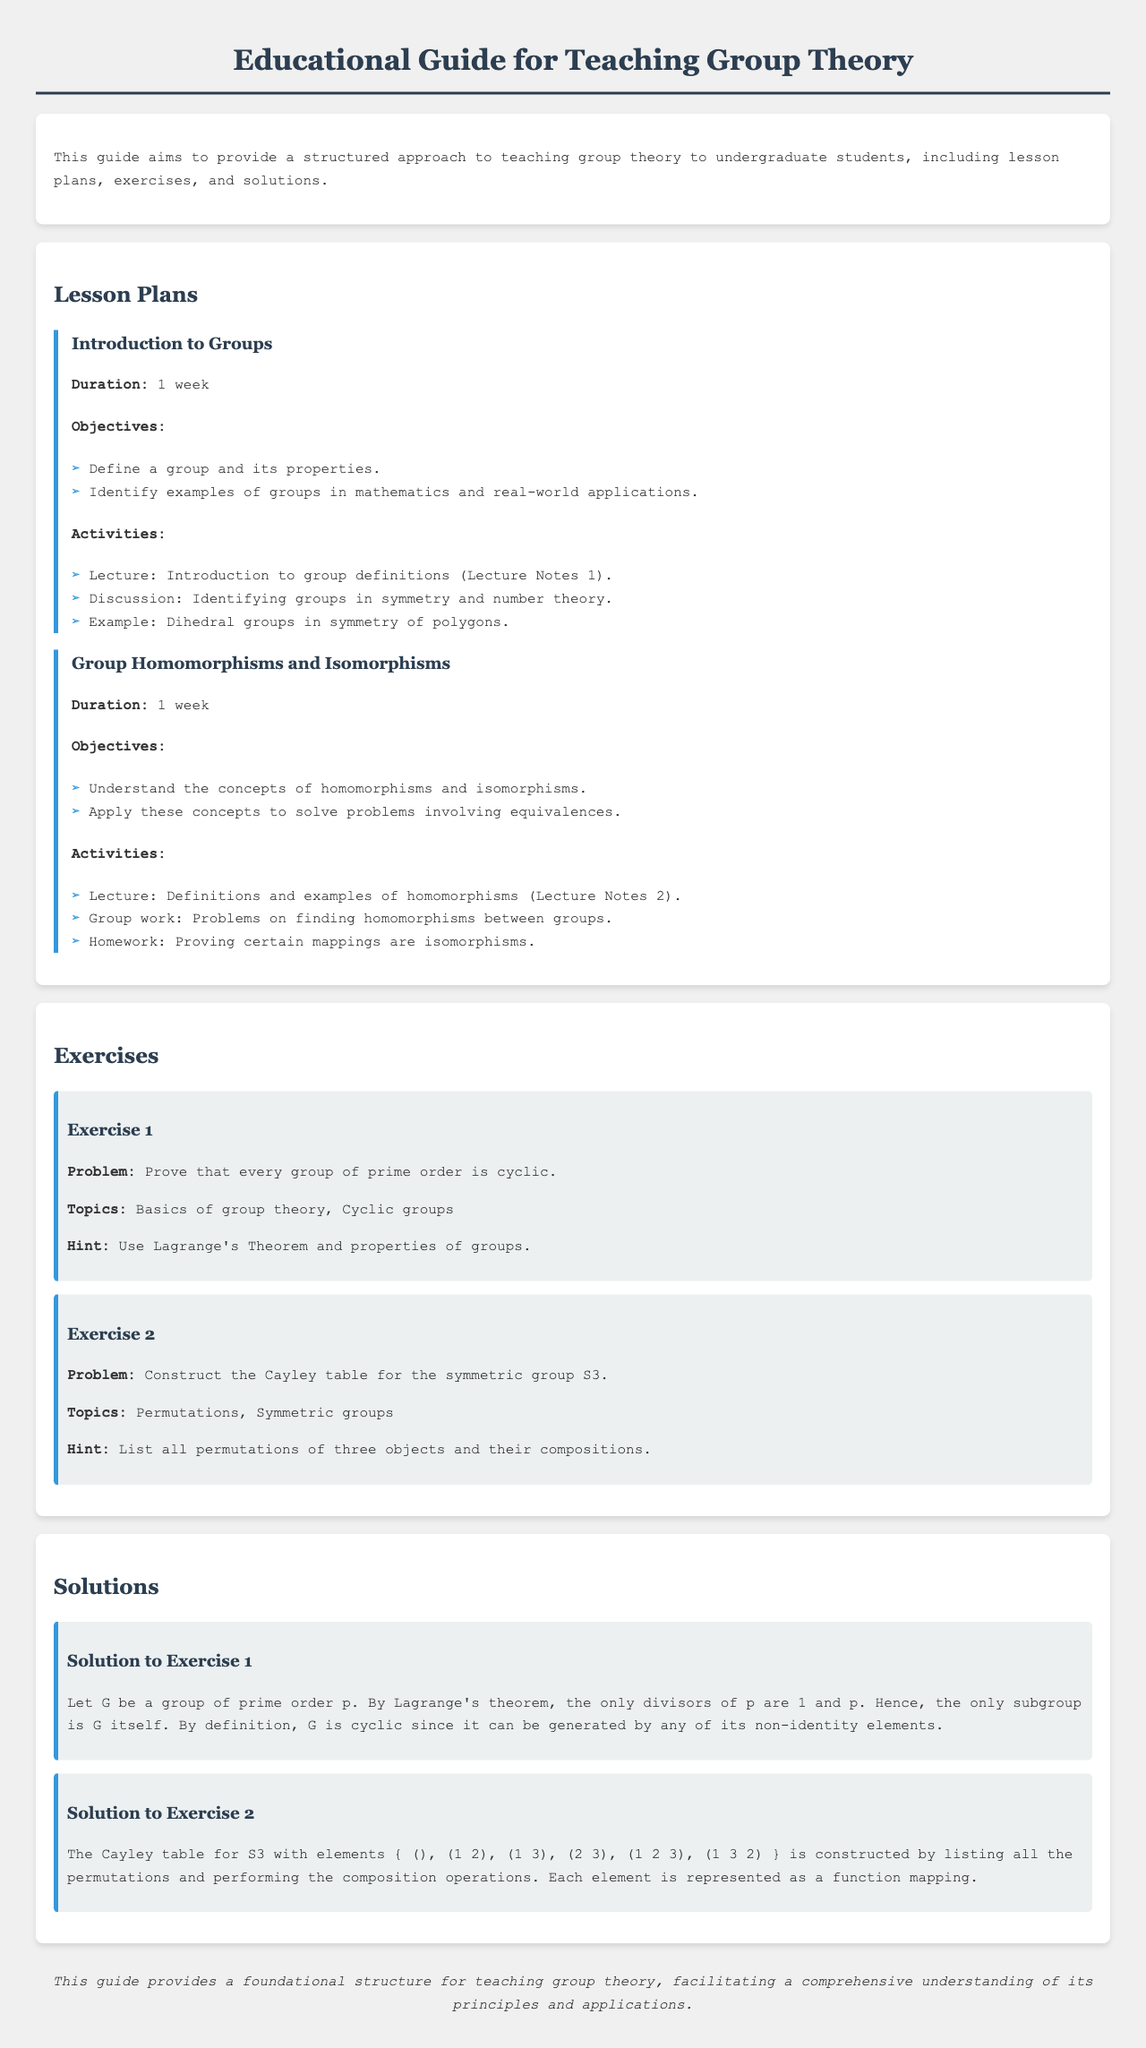What are the two main objectives of the lesson "Introduction to Groups"? The two main objectives are defined in the lesson plan under the "Objectives" section, focusing on defining a group and identifying examples of groups.
Answer: Define a group and its properties; Identify examples of groups in mathematics and real-world applications What is the duration of the lesson on "Group Homomorphisms and Isomorphisms"? The duration is specified in the lesson plan for "Group Homomorphisms and Isomorphisms."
Answer: 1 week What is the topic of Exercise 1? The topic is listed under "Topics" in Exercise 1 and pertains to the concepts necessary to solve the problem.
Answer: Basics of group theory, Cyclic groups What is the hint provided for Exercise 2? The hint is mentioned in the exercise to guide students in solving the problem related to the symmetric group S3.
Answer: List all permutations of three objects and their compositions What is the conclusion of the document? The conclusion summarizes the main purpose and structured approach to teaching group theory, encapsulated in its final paragraph.
Answer: This guide provides a foundational structure for teaching group theory, facilitating a comprehensive understanding of its principles and applications What is the first activity listed for the "Introduction to Groups" lesson? The first activity is found in the Activities section and involves a lecture.
Answer: Lecture: Introduction to group definitions (Lecture Notes 1) 